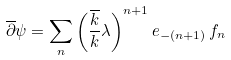Convert formula to latex. <formula><loc_0><loc_0><loc_500><loc_500>\overline { \partial } \psi = \sum _ { n } \left ( \frac { \overline { k } } { k } \lambda \right ) ^ { n + 1 } e _ { - ( n + 1 ) } \, f _ { n }</formula> 